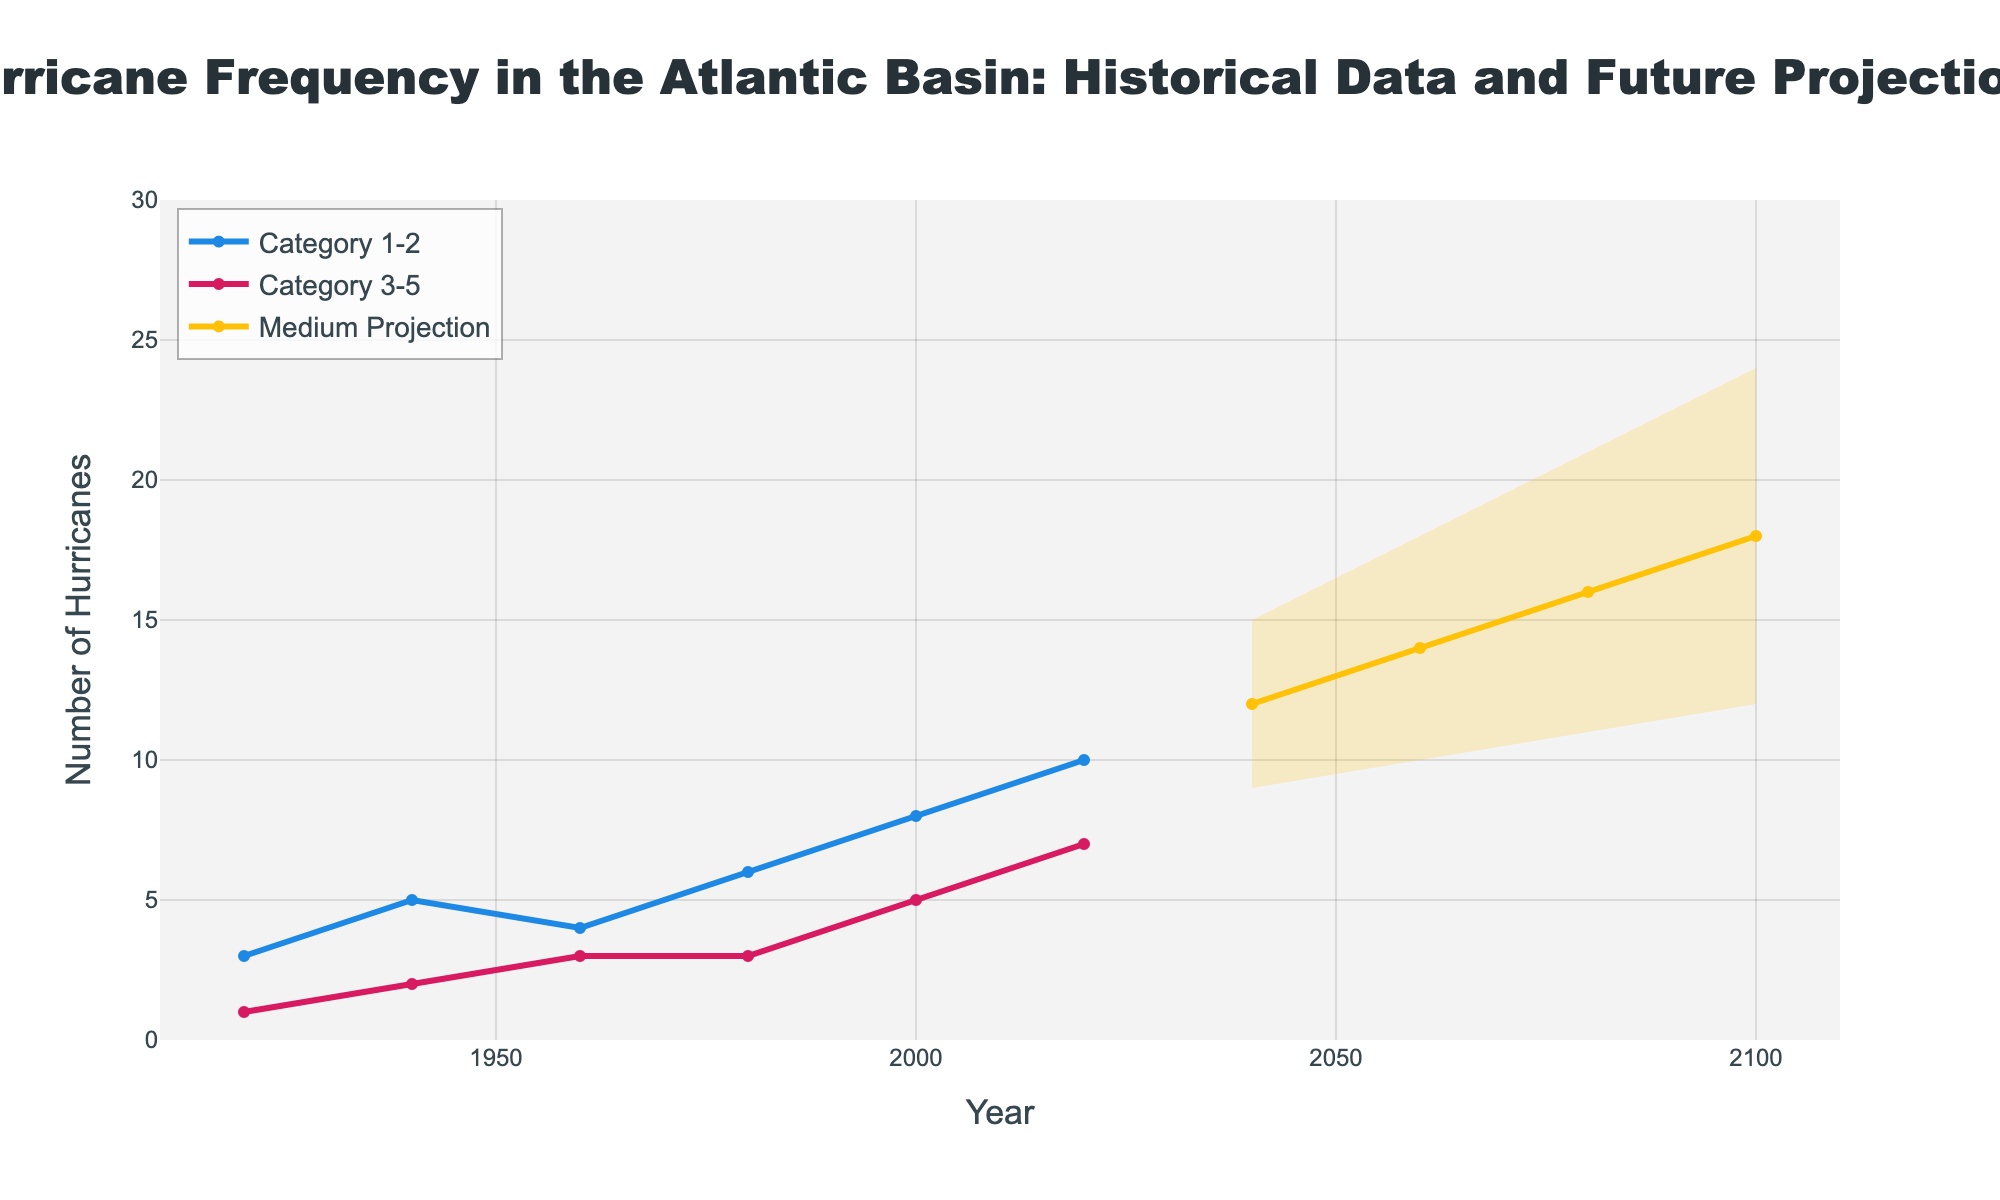When do future projections begin in the chart? The x-axis represents the years ranging from 1920 to 2100. Future projections start from 2040 onwards.
Answer: 2040 How many Category 3-5 hurricanes were recorded in 2020? Locate the year 2020 on the x-axis and check the corresponding point for the Category 3-5 hurricanes, marked by a pink line. In 2020, there were 7 Category 3-5 hurricanes.
Answer: 7 Which category of hurricanes shows a higher number in the historical data: Category 1-2 or Category 3-5? Compare the blue line (Category 1-2) and the pink line (Category 3-5) for historical years (1920-2020). The blue line (Category 1-2) is consistently higher than the pink line (Category 3-5).
Answer: Category 1-2 What is the expected number of hurricanes under the high future projection in 2100? Locate the year 2100 on the x-axis and find the upper boundary of the yellow fan area, which indicates the high projection. The high future projection for 2100 is 24 hurricanes.
Answer: 24 What is the trend in the number of Category 1-2 hurricanes from 1920 to 2020? Observe the blue line representing Category 1-2 hurricanes from 1920 to 2020. The trend shows an increase from 3 hurricanes in 1920 to 10 hurricanes in 2020.
Answer: Increasing What is the difference between the high projection and the low projection for the year 2060? Locate the year 2060 on the x-axis and find the values for the high and low projections. The high projection is 18 hurricanes and the low projection is 10 hurricanes, resulting in a difference of 8 hurricanes.
Answer: 8 Which year shows the same number of Category 1-2 and Category 3-5 hurricanes in historical data? Compare the points on the blue and pink lines in the historical data. In the year 1980, both Category 1-2 and Category 3-5 hurricanes are at 3.
Answer: 1980 Between which years does the number of Category 3-5 hurricanes increase the fastest historically? Examine the slope of the pink line representing Category 3-5 hurricanes. The steepest increase is between the years 1960 and 2000.
Answer: 1960 to 2000 How does the uncertainty in future projections change over time? Observe the width of the yellow fan area between the low and high projections. The uncertainly increases as the projections go further into the future (from 2040 to 2100).
Answer: Increases How many total data points are there in the historical data for Category 1-2 hurricanes? Count the number of points on the blue line from 1920 to 2020. There are 6 data points.
Answer: 6 